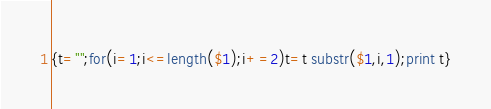<code> <loc_0><loc_0><loc_500><loc_500><_Awk_>{t="";for(i=1;i<=length($1);i+=2)t=t substr($1,i,1);print t}</code> 